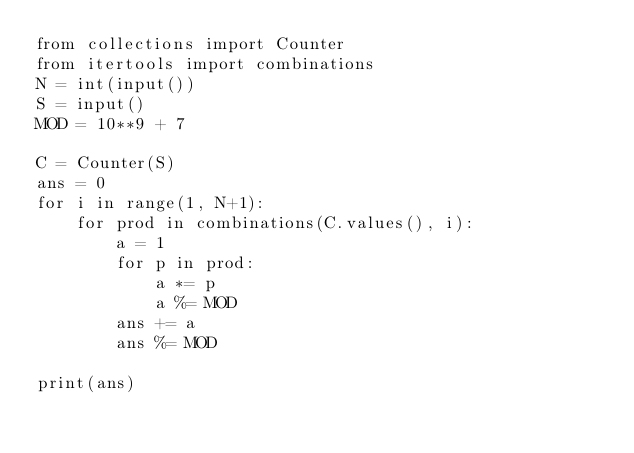<code> <loc_0><loc_0><loc_500><loc_500><_Python_>from collections import Counter
from itertools import combinations
N = int(input())
S = input()
MOD = 10**9 + 7

C = Counter(S)
ans = 0
for i in range(1, N+1):
    for prod in combinations(C.values(), i):
        a = 1
        for p in prod:
            a *= p
            a %= MOD
        ans += a
        ans %= MOD

print(ans)     
</code> 